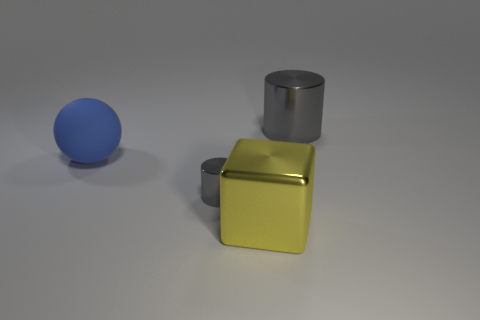Add 2 big green metallic things. How many objects exist? 6 Subtract all large metal cylinders. Subtract all big yellow metal cubes. How many objects are left? 2 Add 2 tiny gray metal cylinders. How many tiny gray metal cylinders are left? 3 Add 2 big gray rubber cylinders. How many big gray rubber cylinders exist? 2 Subtract 0 red cubes. How many objects are left? 4 